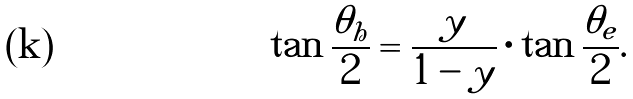Convert formula to latex. <formula><loc_0><loc_0><loc_500><loc_500>\tan \frac { \theta _ { h } } { 2 } = \frac { y } { 1 - y } \cdot \tan \frac { \theta _ { e } } { 2 } .</formula> 